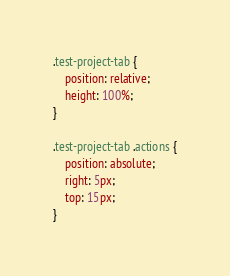<code> <loc_0><loc_0><loc_500><loc_500><_CSS_>.test-project-tab {
    position: relative;
    height: 100%;
}

.test-project-tab .actions {
    position: absolute;
    right: 5px;
    top: 15px;
}</code> 